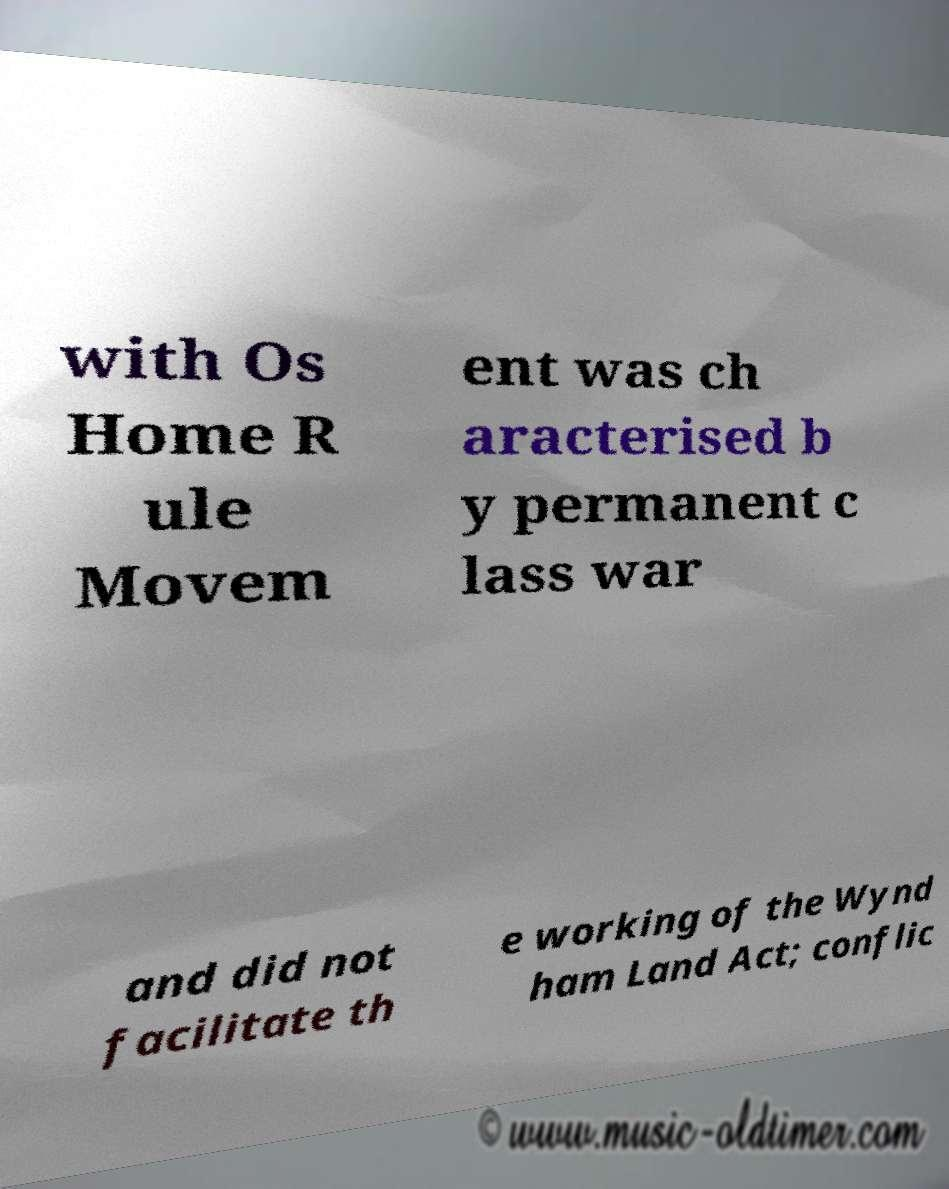What messages or text are displayed in this image? I need them in a readable, typed format. with Os Home R ule Movem ent was ch aracterised b y permanent c lass war and did not facilitate th e working of the Wynd ham Land Act; conflic 